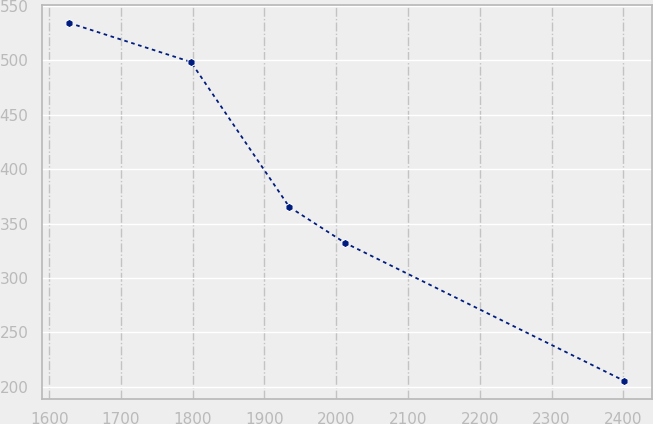<chart> <loc_0><loc_0><loc_500><loc_500><line_chart><ecel><fcel>Unnamed: 1<nl><fcel>1628.09<fcel>534.35<nl><fcel>1797.49<fcel>498.52<nl><fcel>1934.58<fcel>365.24<nl><fcel>2011.86<fcel>332.36<nl><fcel>2400.88<fcel>205.51<nl></chart> 